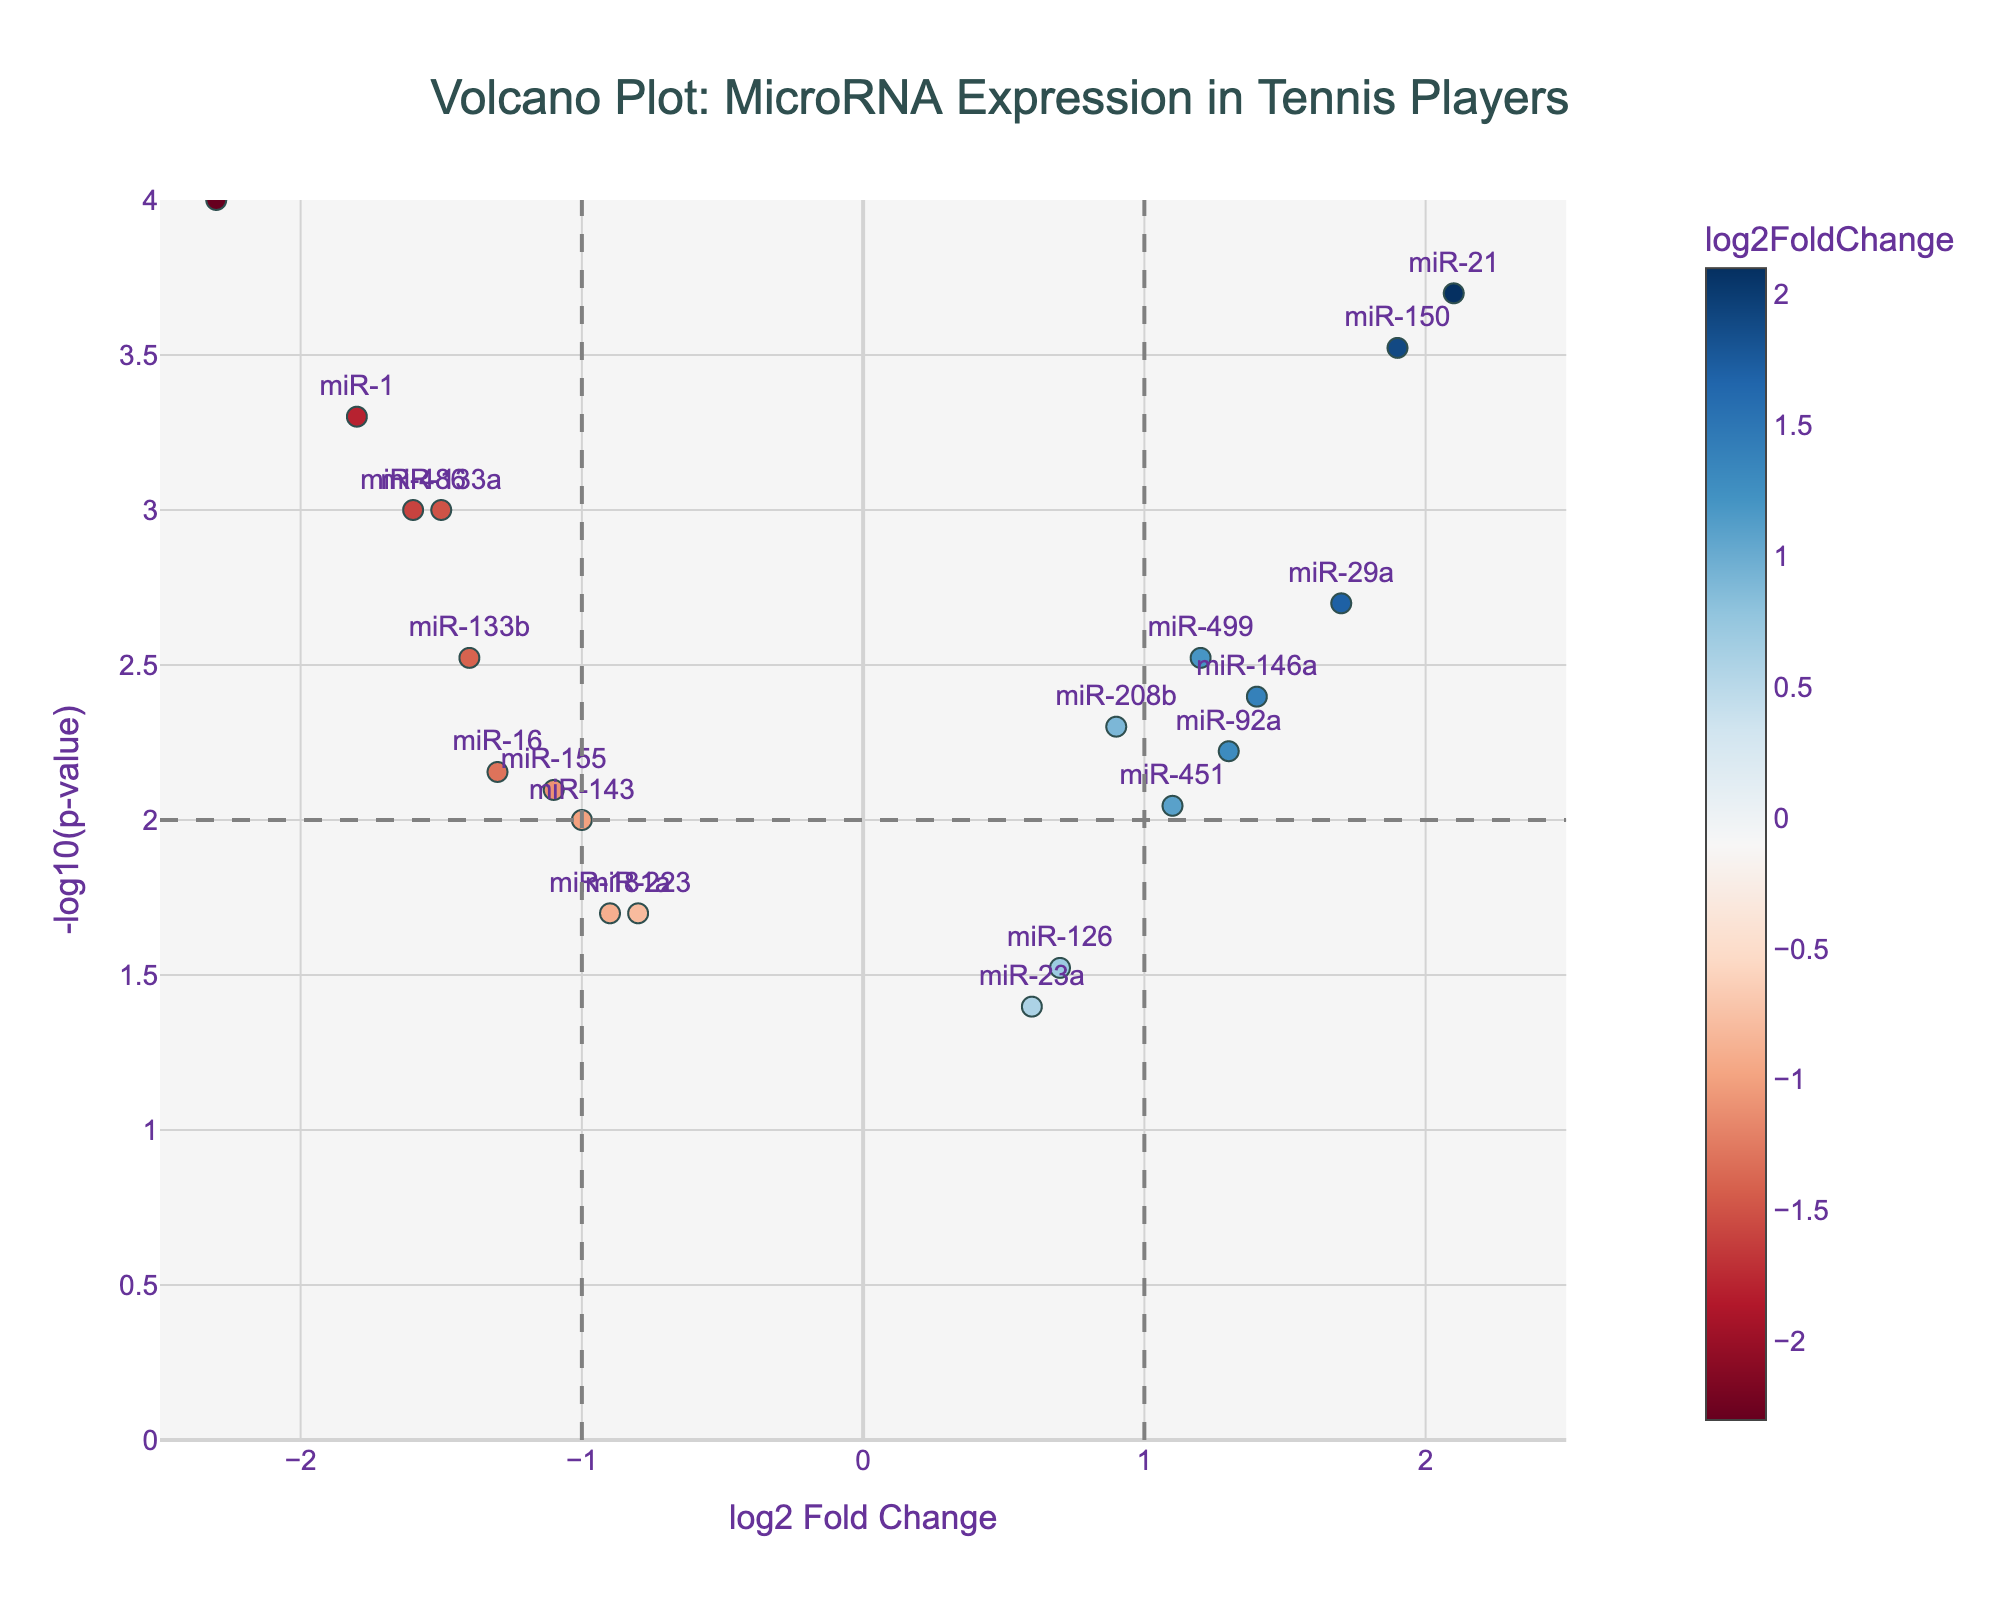what is the title of the plot? The title of the plot is typically displayed at the top of the plot in a larger or bold font to make it distinct and easy to read.
Answer: Volcano Plot: MicroRNA Expression in Tennis Players Which miRNA has the highest log2 fold change? The miRNA with the highest log2 fold change will be the point furthest to the right on the horizontal axis.
Answer: miR-21 Which miRNA are both significantly upregulated and downregulated? Significantly altered miRNAs can be identified by looking for data points with high -log10(p-value) and large absolute values of log2 fold change. The miRNAs with colors leaning towards red or blue may indicate either upregulation (positive log2 fold change) or downregulation (negative log2 fold change).
Answer: Upregulated: miR-21. Downregulated: miR-206 How many miRNAs have a -log10(p-value) greater than 2? Look for the number of points above the horizontal threshold line at -log10(p-value) = 2
Answer: 8 What is the log2 fold change and p-value of miR-29a? Hovering over the point corresponding to miR-29a will display the log2 fold change and p-value associated with it.
Answer: log2 Fold Change: 1.7, p-value: 0.002 Which vertical lines indicate the threshold for significant fold change? Vertical lines usually serve as thresholds or guidelines. The dashed vertical lines in this plot indicate the significant fold change thresholds.
Answer: log2 Fold Change = -1 and log2 Fold Change = 1 How does the expression of miR-1 compare to miR-21 in terms of fold change? To compare the fold change, look at the x-axis positions of the miR-1 and miR-21 points. miR-1 will be located towards the left (negative log2 fold change), while miR-21 will be towards the right (positive log2 fold change).
Answer: miR-1 has a lower (negative) fold change than miR-21 Which miRNA has the lowest p-value? The miRNA with the lowest p-value will have the highest -log10(p-value) and be the highest point on the y-axis.
Answer: miR-206 Are there more upregulated or downregulated miRNAs? Count the number of points to the right of log2 Fold Change = 0 (upregulated) and to the left (downregulated).
Answer: More downregulated miRNAs What does the color gradient represent in this plot? The color gradient is often explained in the plot’s legend. Look at the legend to understand what the color differences represent.
Answer: log2 Fold Change 